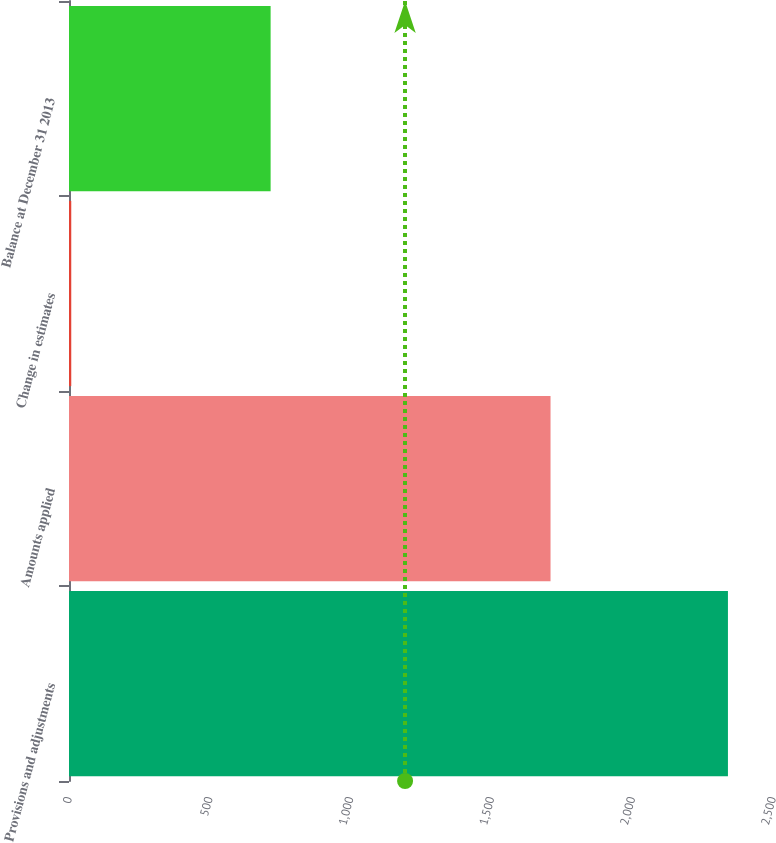Convert chart to OTSL. <chart><loc_0><loc_0><loc_500><loc_500><bar_chart><fcel>Provisions and adjustments<fcel>Amounts applied<fcel>Change in estimates<fcel>Balance at December 31 2013<nl><fcel>2340<fcel>1710<fcel>8<fcel>716<nl></chart> 